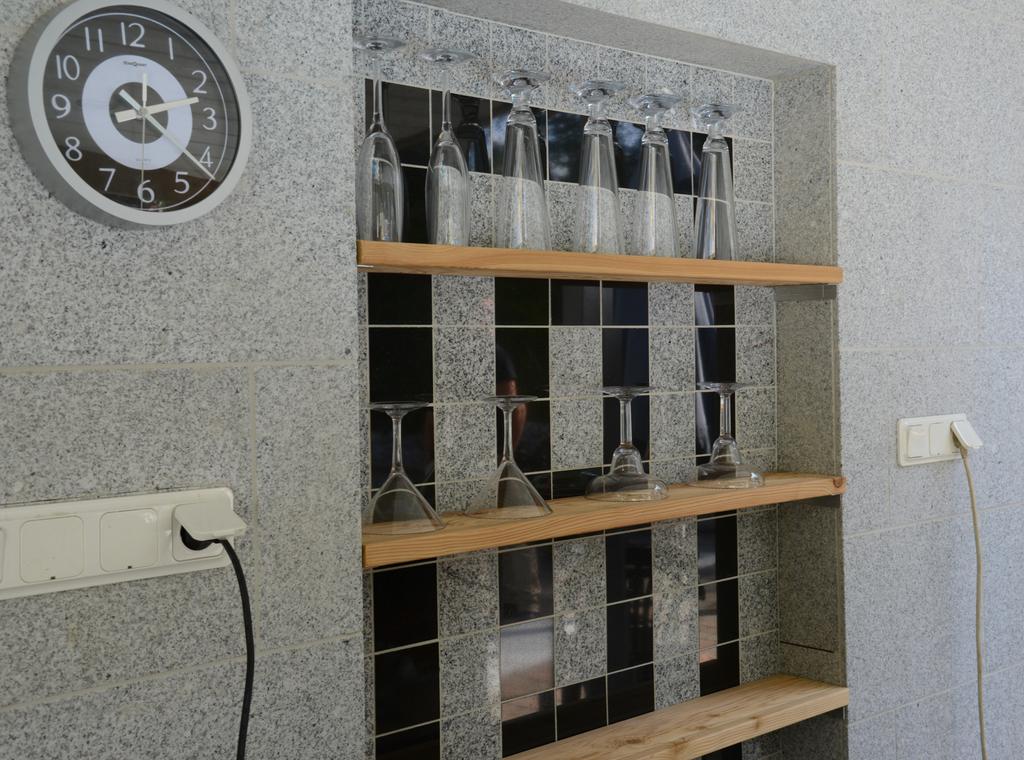What time is it?
Provide a short and direct response. 2:20. 